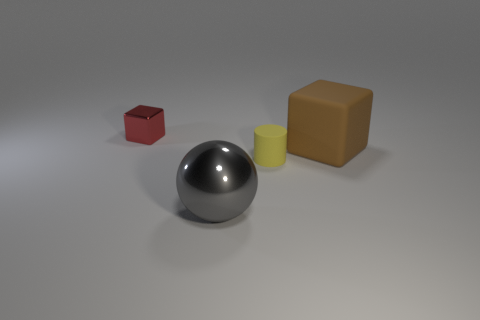How many rubber objects are either spheres or large gray cylinders?
Offer a very short reply. 0. Is the number of tiny gray shiny spheres less than the number of yellow matte cylinders?
Your answer should be very brief. Yes. There is a brown matte object; is it the same size as the metallic object that is in front of the matte cylinder?
Give a very brief answer. Yes. Is there any other thing that is the same shape as the small metal object?
Your response must be concise. Yes. The red shiny object has what size?
Ensure brevity in your answer.  Small. Is the number of yellow rubber things behind the small metallic block less than the number of big gray balls?
Your answer should be compact. Yes. Does the yellow matte cylinder have the same size as the brown object?
Ensure brevity in your answer.  No. Are there any other things that have the same size as the rubber block?
Give a very brief answer. Yes. There is a object that is the same material as the tiny cylinder; what color is it?
Your response must be concise. Brown. Are there fewer tiny red shiny things behind the cylinder than cylinders that are to the left of the red metal thing?
Your answer should be compact. No. 